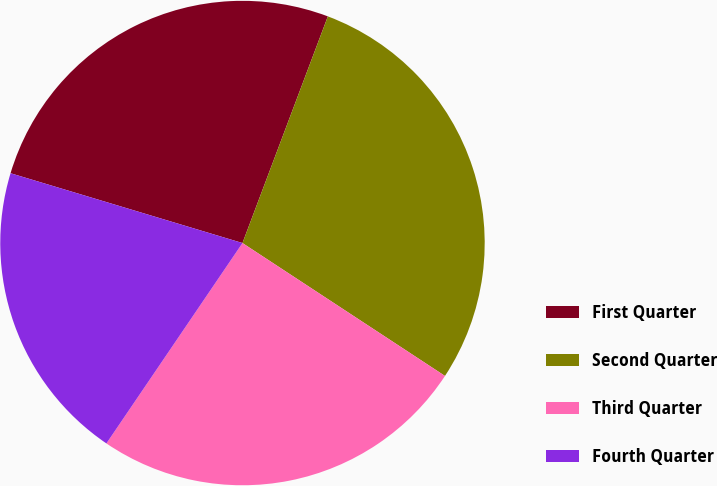Convert chart to OTSL. <chart><loc_0><loc_0><loc_500><loc_500><pie_chart><fcel>First Quarter<fcel>Second Quarter<fcel>Third Quarter<fcel>Fourth Quarter<nl><fcel>26.08%<fcel>28.51%<fcel>25.25%<fcel>20.16%<nl></chart> 